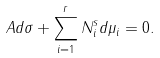Convert formula to latex. <formula><loc_0><loc_0><loc_500><loc_500>A d \sigma + \sum _ { i = 1 } ^ { r } N _ { i } ^ { s } d \mu _ { i } = 0 .</formula> 